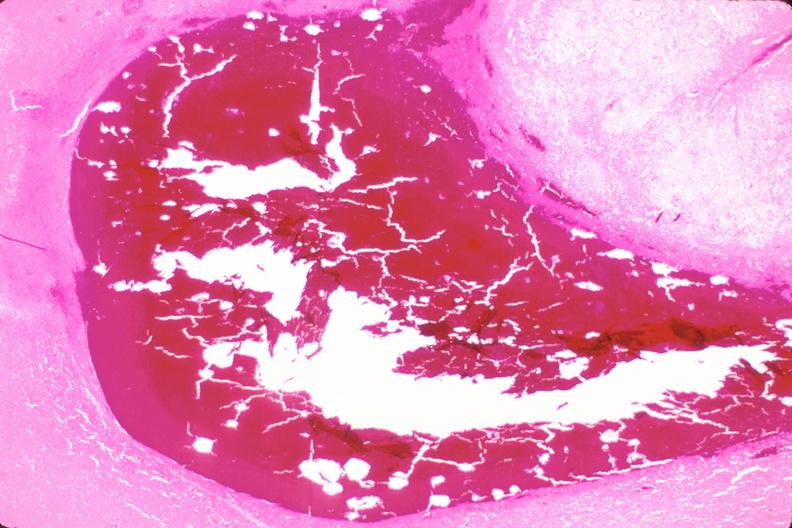what is present?
Answer the question using a single word or phrase. Nervous 